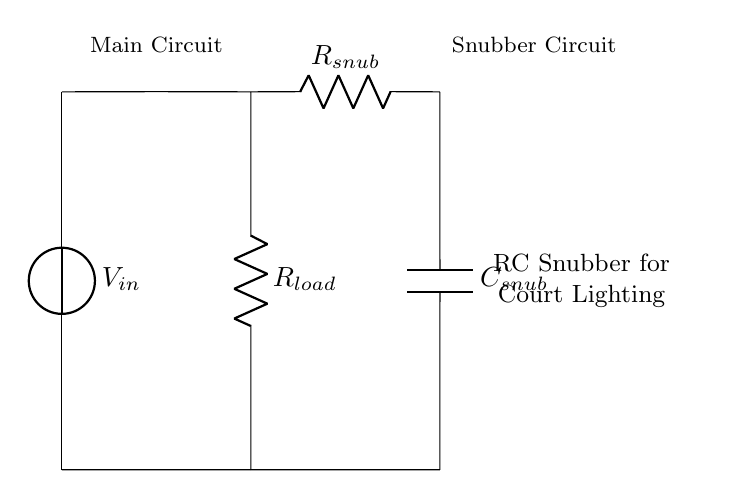What components are present in the circuit? The circuit contains a voltage source, a load resistor, a snubber resistor, and a snubber capacitor.
Answer: voltage source, load resistor, snubber resistor, snubber capacitor What is the role of the RC snubber circuit? The RC snubber circuit is used to protect electrical components by damping voltage spikes and reducing electromagnetic interference.
Answer: To protect components How many resistors are in the circuit? The circuit has two resistors: one is the load resistor, and the other is the snubber resistor.
Answer: Two resistors What is the position of the snubber capacitor in the circuit? The snubber capacitor is connected in parallel with the load resistor, after the snubber resistor.
Answer: Parallel to the load resistor What would happen if the capacitor is too small in the snubber circuit? If the capacitor is too small, it may not effectively dampen the voltage spikes, leading to potential damage to the connected components.
Answer: Insufficient damping Why is an RC snubber preferred over other protection methods? An RC snubber is preferred because it effectively suppresses voltage spikes while providing a simple and cost-effective solution for transient suppression.
Answer: Simple and effective 